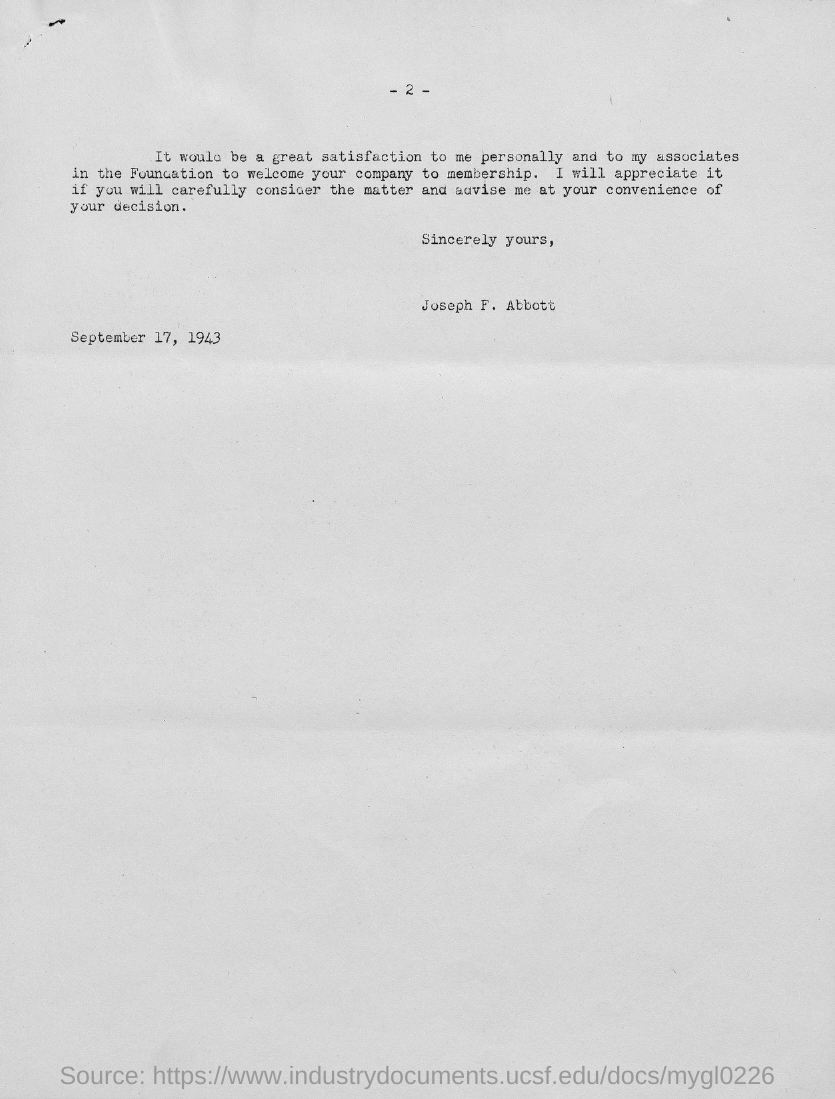Specify some key components in this picture. The date mentioned in the letter is September 17, 1943. The letter was written by Joseph F. Abbott. The page number written at the top of the page is -2-. 